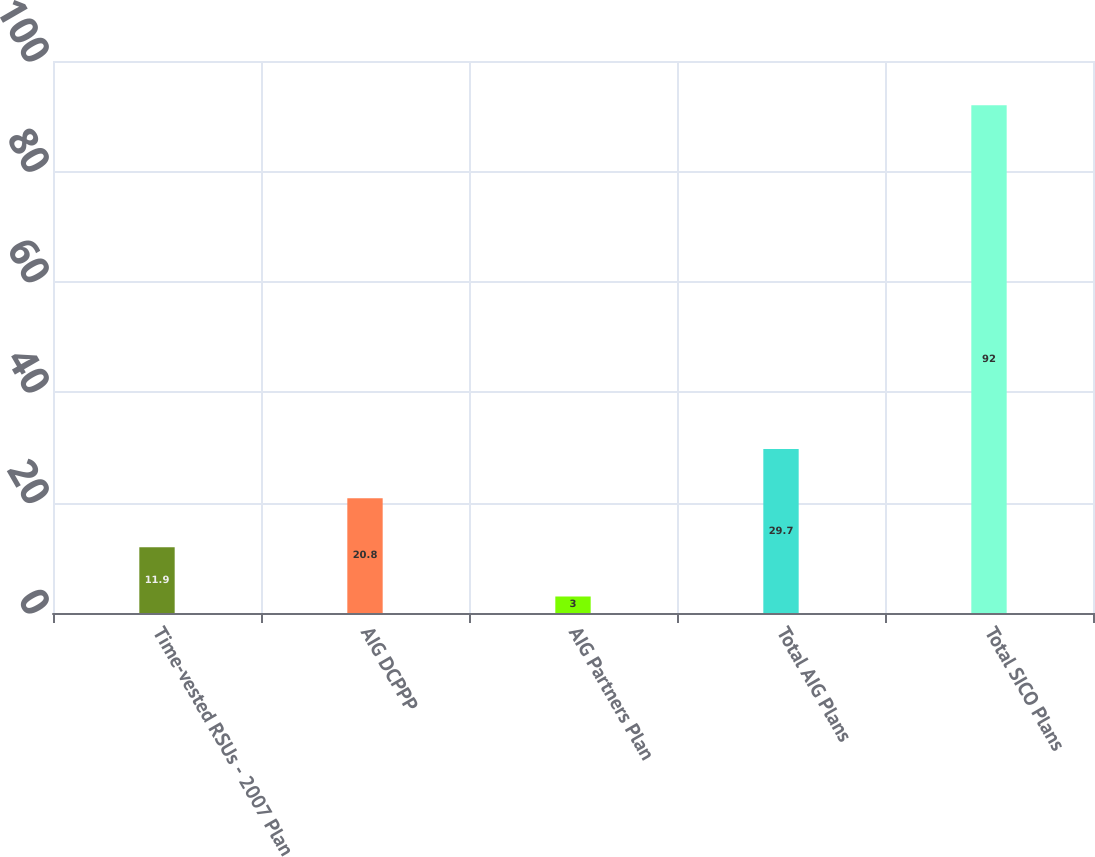<chart> <loc_0><loc_0><loc_500><loc_500><bar_chart><fcel>Time-vested RSUs - 2007 Plan<fcel>AIG DCPPP<fcel>AIG Partners Plan<fcel>Total AIG Plans<fcel>Total SICO Plans<nl><fcel>11.9<fcel>20.8<fcel>3<fcel>29.7<fcel>92<nl></chart> 